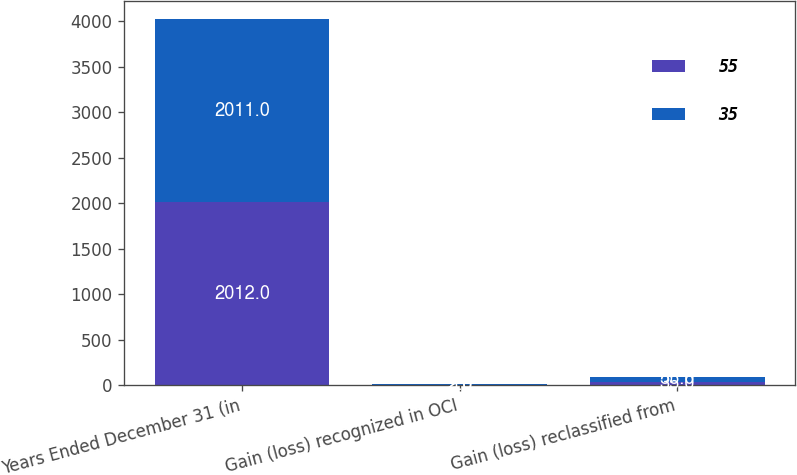Convert chart to OTSL. <chart><loc_0><loc_0><loc_500><loc_500><stacked_bar_chart><ecel><fcel>Years Ended December 31 (in<fcel>Gain (loss) recognized in OCI<fcel>Gain (loss) reclassified from<nl><fcel>55<fcel>2012<fcel>2<fcel>35<nl><fcel>35<fcel>2011<fcel>5<fcel>55<nl></chart> 